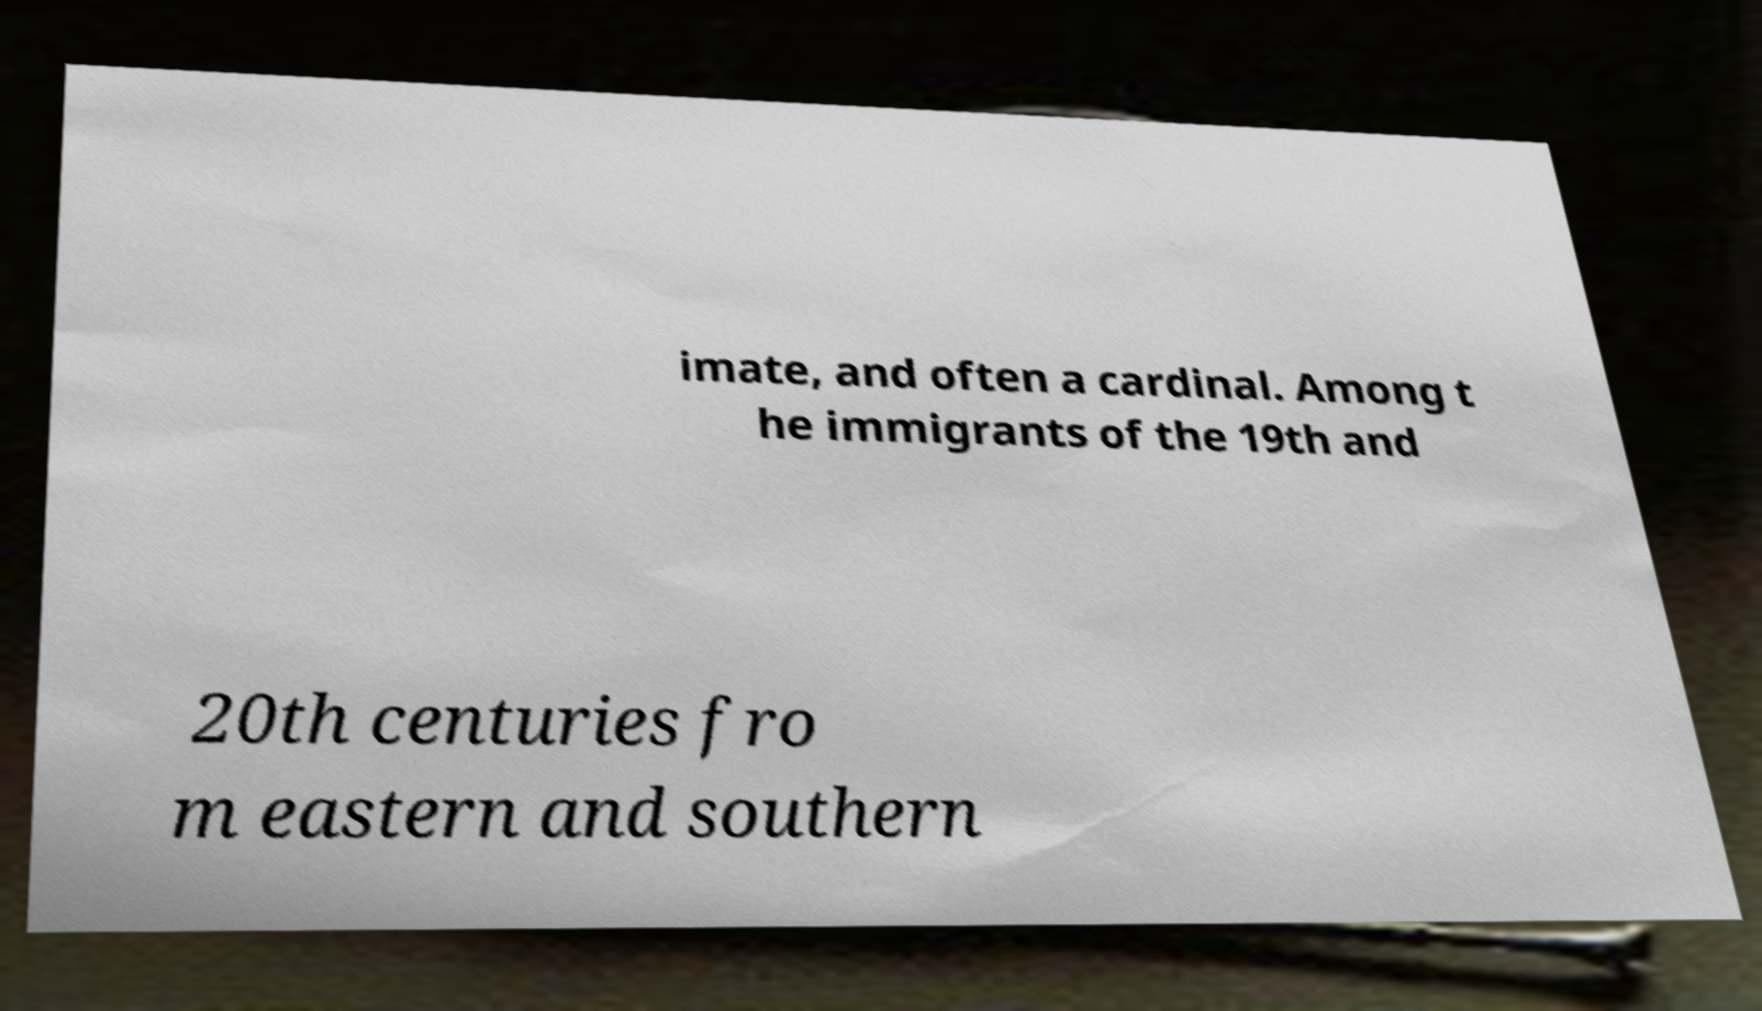There's text embedded in this image that I need extracted. Can you transcribe it verbatim? imate, and often a cardinal. Among t he immigrants of the 19th and 20th centuries fro m eastern and southern 